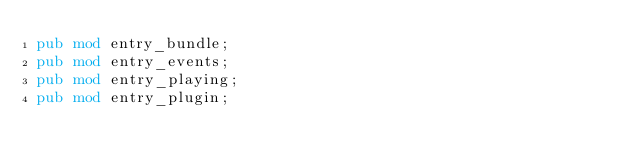<code> <loc_0><loc_0><loc_500><loc_500><_Rust_>pub mod entry_bundle;
pub mod entry_events;
pub mod entry_playing;
pub mod entry_plugin;
</code> 